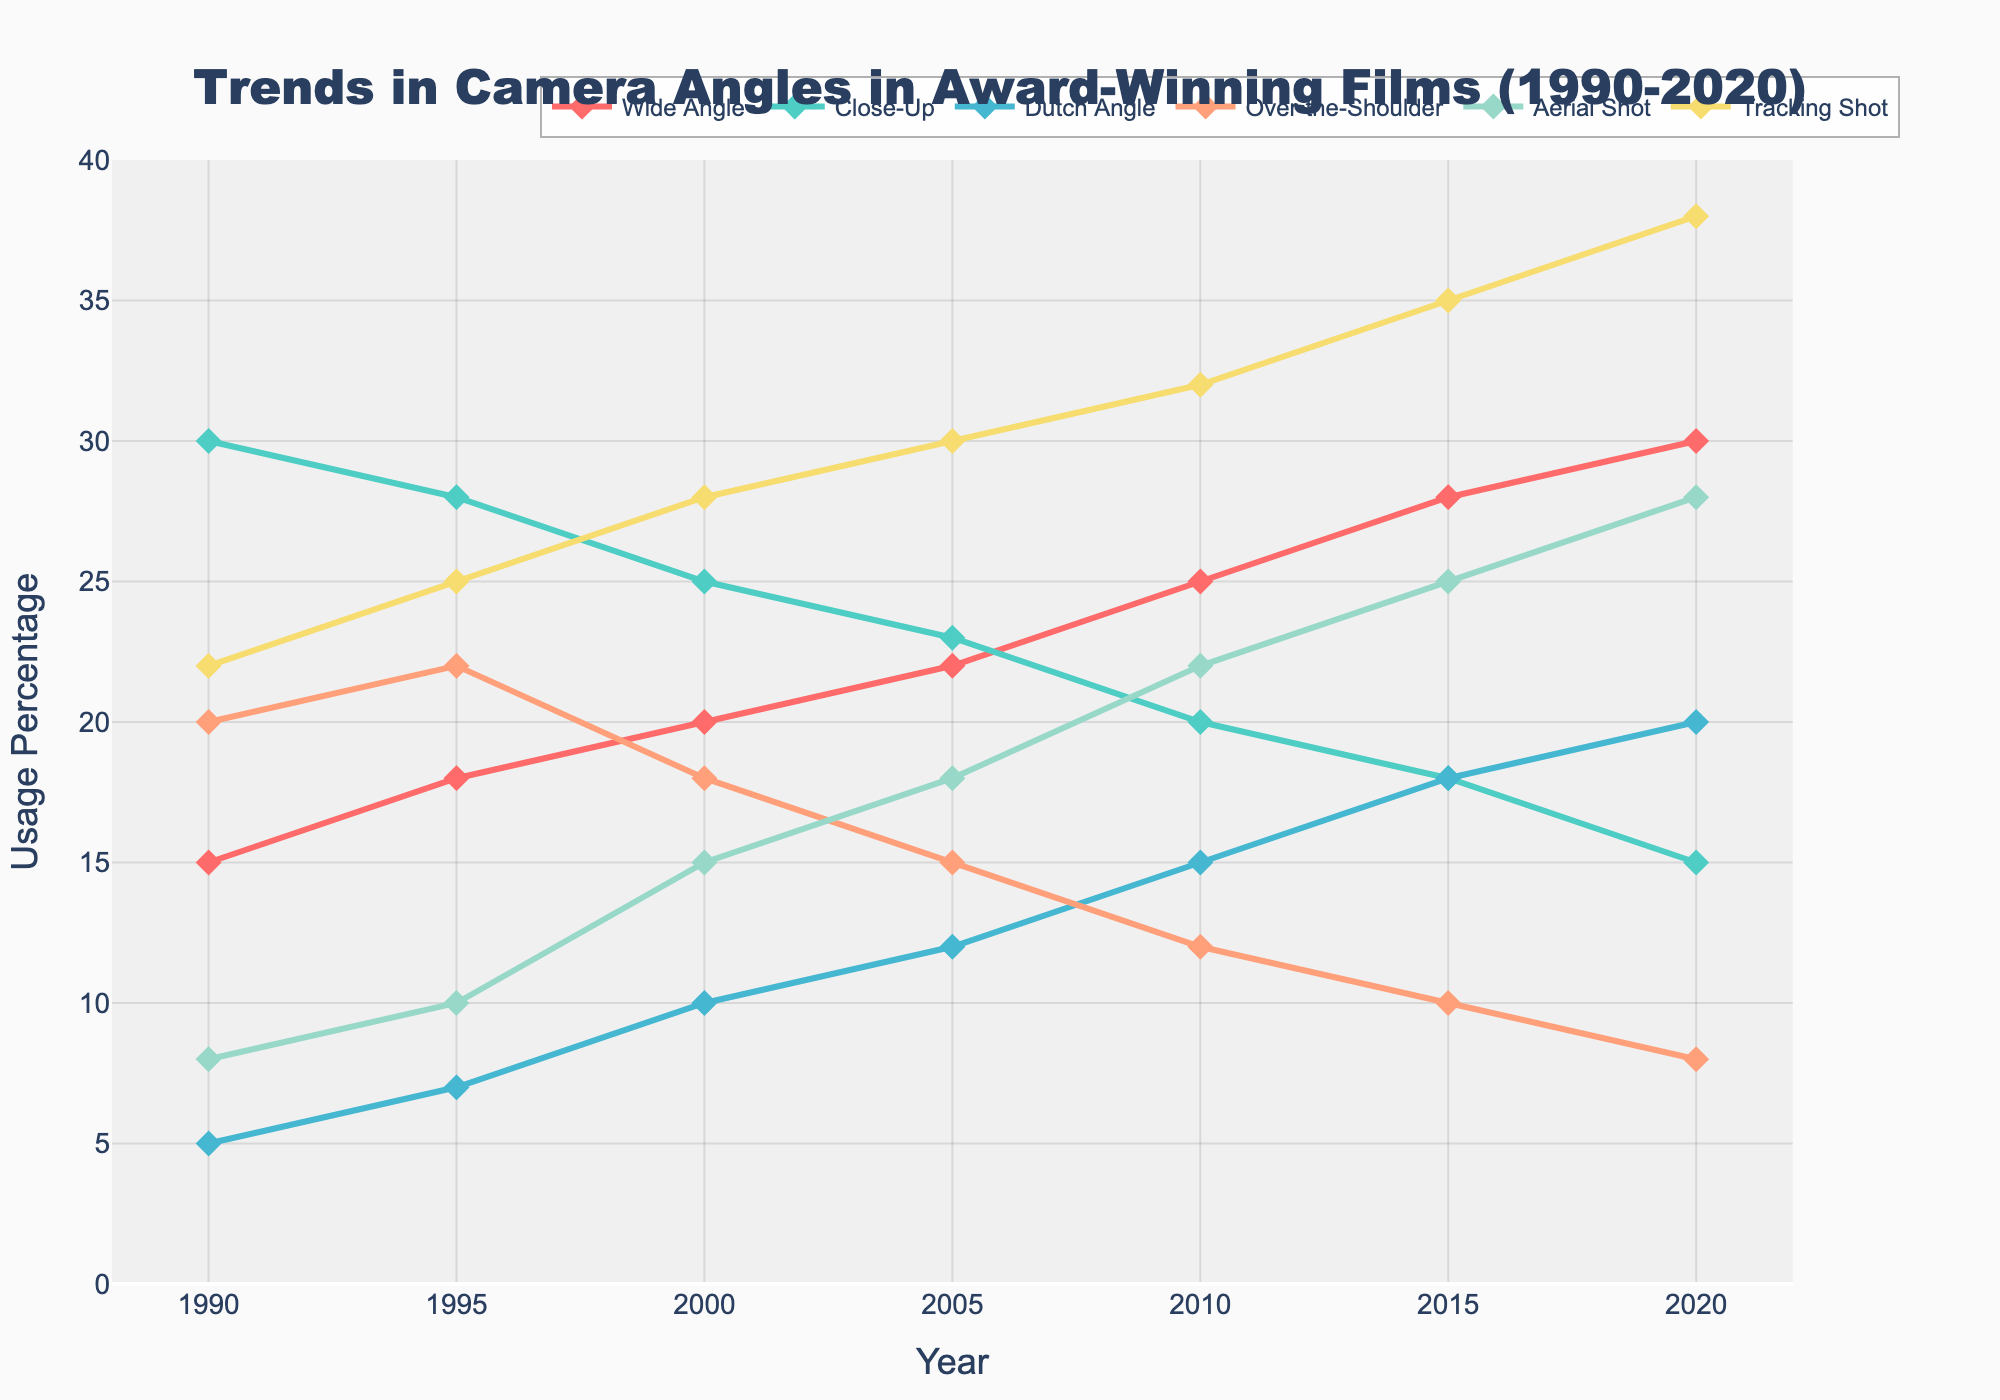What trend can be observed in the usage of the Aerial Shot over the last three decades? The Aerial Shot usage has a consistent upward trend. It starts at 8% in 1990 and increases gradually to 28% in 2020.
Answer: Increasing trend Which camera angle shows a decreasing trend in usage between 1990 and 2020? The Close-Up shot shows a decreasing trend. It starts at 30% in 1990 and drops to 15% by 2020.
Answer: Close-Up Between which two consecutive years does the usage of the Tracking Shot see the largest increase? The usage sees the largest increase between 2015 and 2020, where it goes up from 35% to 38%, an increase of 3%.
Answer: Between 2015 and 2020 What is the sum of the usage percentages of all camera angles in the year 2000? The sum is calculated as follows: 20 (Wide Angle) + 25 (Close-Up) + 10 (Dutch Angle) + 18 (Over-the-Shoulder) + 15 (Aerial Shot) + 28 (Tracking Shot) = 116%.
Answer: 116 Which camera angle had the highest usage percentage in 2015, and what was that percentage? The Tracking Shot had the highest usage percentage in 2015 with 35%.
Answer: Tracking Shot, 35% Compare the usage of Dutch Angle in 1990 and 2020. Which year had higher usage, and by how much? In 1990, the usage was 5%, and in 2020, it was 20%. Therefore, 2020 had a higher usage by 15 percentage points.
Answer: 2020, by 15% Which camera angle showed the most consistent trend (least variation) over the three decades? The Consistent trend can be identified from the visual representation, where the Dutch Angle shows a relatively steady increase without drastic fluctuations compared to others.
Answer: Dutch Angle What is the average usage percentage of the Over-the-Shoulder shot across all the years provided? Sum of usage from 1990 to 2020: 20+22+18+15+12+10+8 = 105. There are 7 data points, so 105 / 7 = 15%.
Answer: 15 